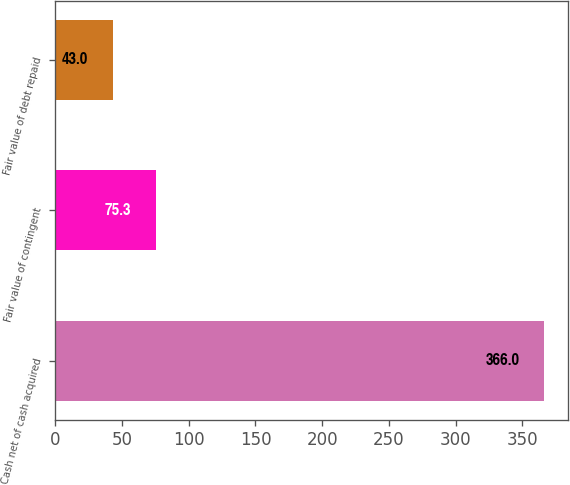<chart> <loc_0><loc_0><loc_500><loc_500><bar_chart><fcel>Cash net of cash acquired<fcel>Fair value of contingent<fcel>Fair value of debt repaid<nl><fcel>366<fcel>75.3<fcel>43<nl></chart> 